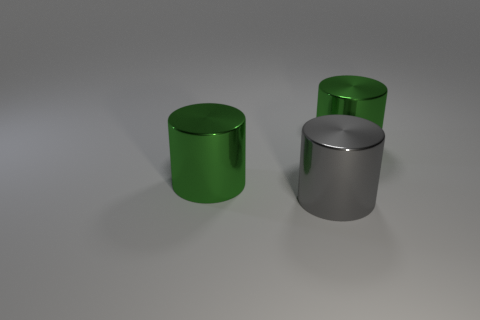What number of other objects are the same shape as the large gray thing?
Your answer should be very brief. 2. How many other things are there of the same material as the big gray object?
Provide a short and direct response. 2. What material is the green cylinder behind the green object left of the green object right of the gray metal object?
Ensure brevity in your answer.  Metal. What number of cylinders are either big metallic objects or big green shiny objects?
Provide a succinct answer. 3. There is a cylinder left of the gray thing; what is its color?
Make the answer very short. Green. How many shiny things are either large cylinders or green cylinders?
Your response must be concise. 3. What is the material of the green object that is on the left side of the large green metal object that is right of the gray thing?
Your answer should be compact. Metal. There is a big green cylinder to the left of the gray thing; are there any big green shiny objects left of it?
Offer a terse response. No. What material is the big gray cylinder?
Offer a very short reply. Metal. Does the object right of the big gray metallic cylinder have the same material as the green cylinder that is to the left of the large gray shiny cylinder?
Make the answer very short. Yes. 